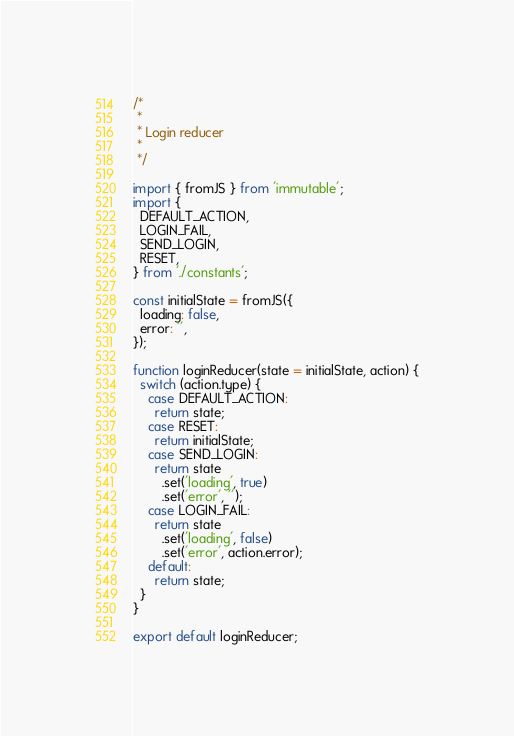Convert code to text. <code><loc_0><loc_0><loc_500><loc_500><_JavaScript_>/*
 *
 * Login reducer
 *
 */

import { fromJS } from 'immutable';
import {
  DEFAULT_ACTION,
  LOGIN_FAIL,
  SEND_LOGIN,
  RESET,
} from './constants';

const initialState = fromJS({
  loading: false,
  error: '',
});

function loginReducer(state = initialState, action) {
  switch (action.type) {
    case DEFAULT_ACTION:
      return state;
    case RESET:
      return initialState;
    case SEND_LOGIN:
      return state
        .set('loading', true)
        .set('error', '');
    case LOGIN_FAIL:
      return state
        .set('loading', false)
        .set('error', action.error);
    default:
      return state;
  }
}

export default loginReducer;
</code> 